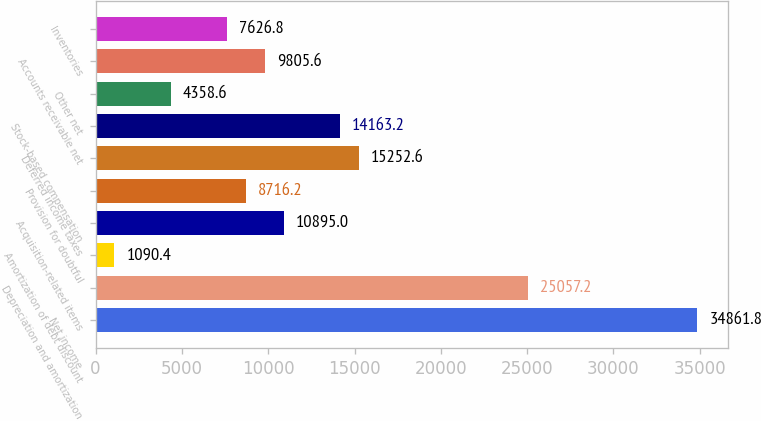Convert chart to OTSL. <chart><loc_0><loc_0><loc_500><loc_500><bar_chart><fcel>Net income<fcel>Depreciation and amortization<fcel>Amortization of debt discount<fcel>Acquisition-related items<fcel>Provision for doubtful<fcel>Deferred income taxes<fcel>Stock-based compensation<fcel>Other net<fcel>Accounts receivable net<fcel>Inventories<nl><fcel>34861.8<fcel>25057.2<fcel>1090.4<fcel>10895<fcel>8716.2<fcel>15252.6<fcel>14163.2<fcel>4358.6<fcel>9805.6<fcel>7626.8<nl></chart> 